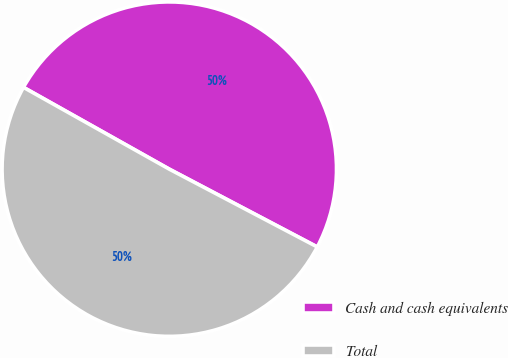<chart> <loc_0><loc_0><loc_500><loc_500><pie_chart><fcel>Cash and cash equivalents<fcel>Total<nl><fcel>49.57%<fcel>50.43%<nl></chart> 